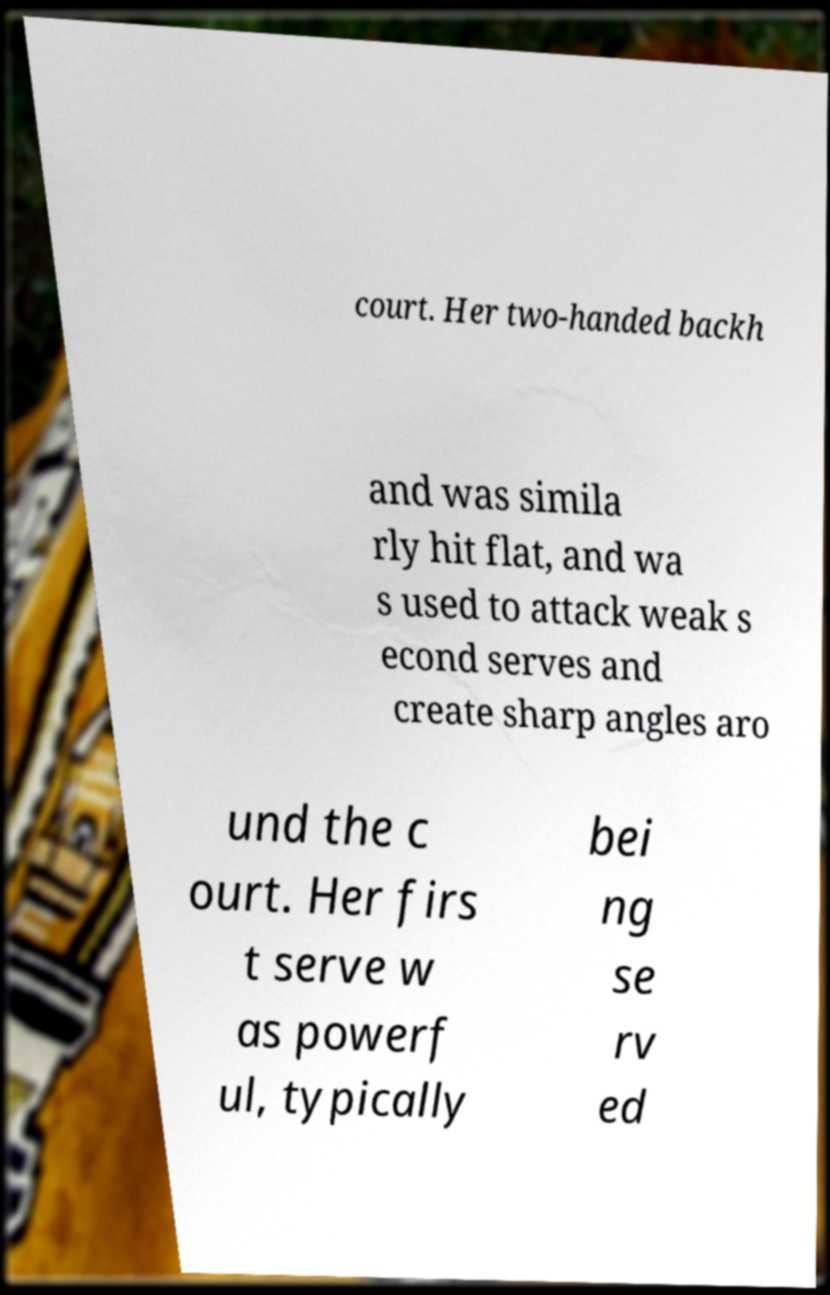Could you extract and type out the text from this image? court. Her two-handed backh and was simila rly hit flat, and wa s used to attack weak s econd serves and create sharp angles aro und the c ourt. Her firs t serve w as powerf ul, typically bei ng se rv ed 